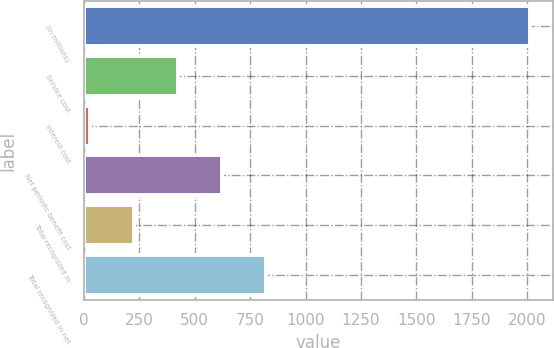<chart> <loc_0><loc_0><loc_500><loc_500><bar_chart><fcel>(in millions)<fcel>Service cost<fcel>Interest cost<fcel>Net periodic benefit cost<fcel>Total recognized in<fcel>Total recognized in net<nl><fcel>2014<fcel>426<fcel>29<fcel>624.5<fcel>227.5<fcel>823<nl></chart> 